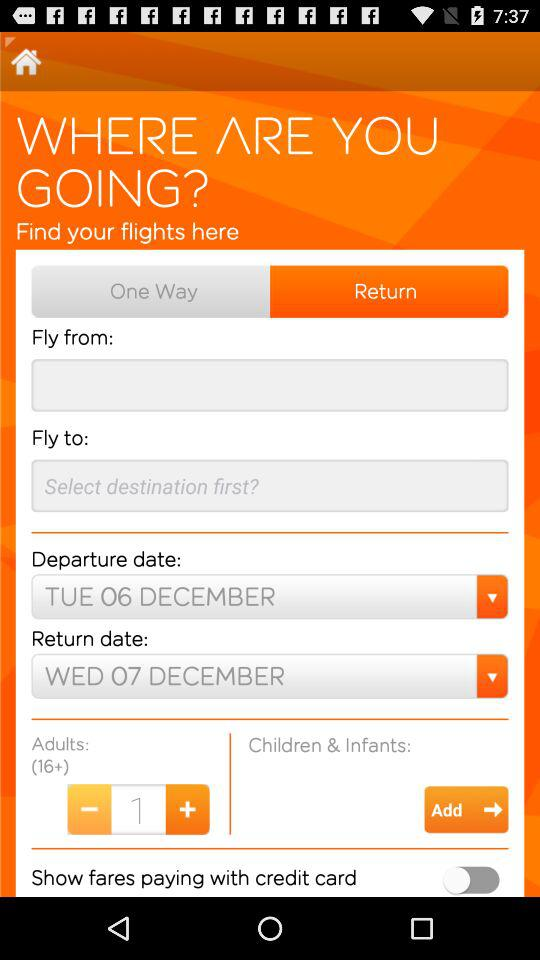What is the return date? The return date is Wednesday, December 7. 